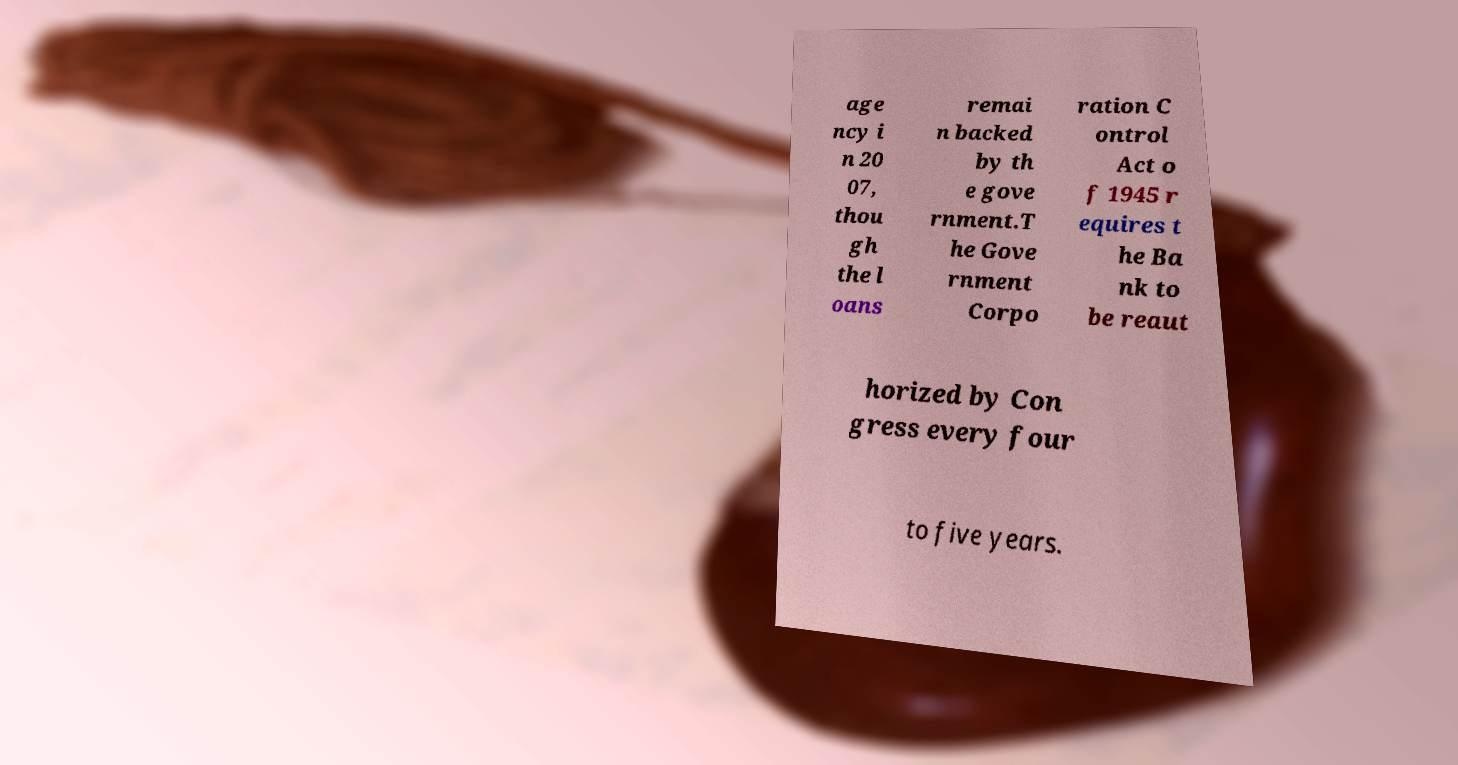There's text embedded in this image that I need extracted. Can you transcribe it verbatim? age ncy i n 20 07, thou gh the l oans remai n backed by th e gove rnment.T he Gove rnment Corpo ration C ontrol Act o f 1945 r equires t he Ba nk to be reaut horized by Con gress every four to five years. 